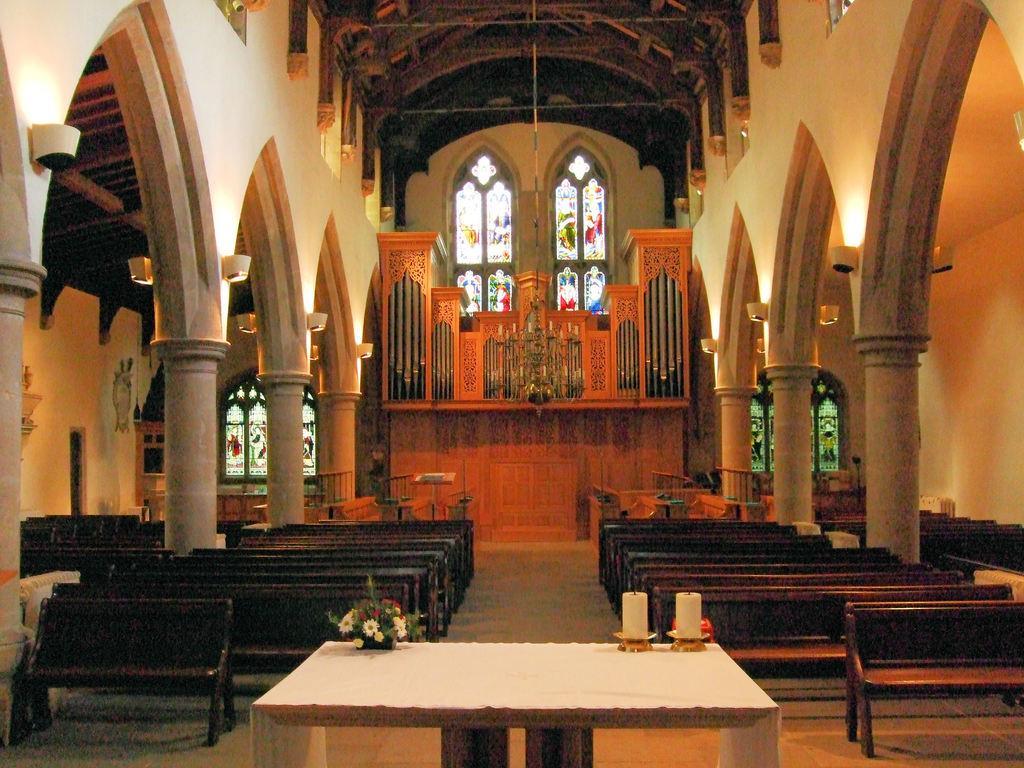Can you describe this image briefly? In the picture we can see inside view of the church with two rows of benches and a table, and on the table, we can see two candles and a plant with flowers and in the background we can see the wall with an architecture to it. 